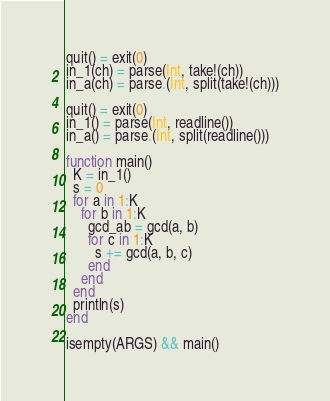Convert code to text. <code><loc_0><loc_0><loc_500><loc_500><_Julia_>quit() = exit(0)
in_1(ch) = parse(Int, take!(ch))
in_a(ch) = parse.(Int, split(take!(ch)))

quit() = exit(0)
in_1() = parse(Int, readline())
in_a() = parse.(Int, split(readline()))

function main()
  K = in_1()
  s = 0
  for a in 1:K
    for b in 1:K
      gcd_ab = gcd(a, b)
      for c in 1:K
        s += gcd(a, b, c)
      end
    end
  end
  println(s)
end

isempty(ARGS) && main()
</code> 